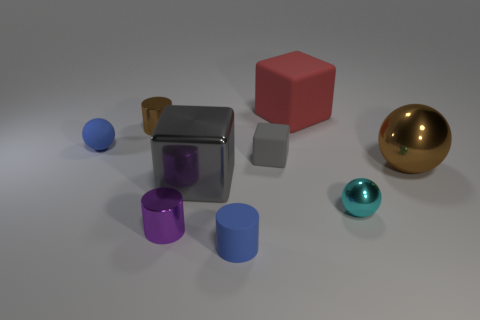Are there any cyan things that have the same shape as the gray metal object?
Your response must be concise. No. What shape is the brown thing that is the same size as the rubber cylinder?
Your answer should be very brief. Cylinder. There is a small blue thing that is to the right of the tiny metallic cylinder that is behind the big brown metallic thing; is there a tiny matte cylinder that is on the left side of it?
Make the answer very short. No. Are there any rubber cylinders of the same size as the brown sphere?
Make the answer very short. No. How big is the metallic cylinder behind the blue matte sphere?
Provide a succinct answer. Small. The large shiny thing that is left of the small cyan shiny ball that is to the right of the blue matte thing behind the rubber cylinder is what color?
Offer a terse response. Gray. What is the color of the small matte object in front of the big metallic object to the left of the blue rubber cylinder?
Provide a short and direct response. Blue. Are there more small blue things that are in front of the gray rubber thing than tiny rubber cubes that are on the left side of the large metal cube?
Your answer should be very brief. Yes. Is the purple cylinder left of the shiny cube made of the same material as the brown ball that is behind the purple shiny thing?
Offer a terse response. Yes. Are there any blue rubber balls on the right side of the large brown ball?
Your response must be concise. No. 